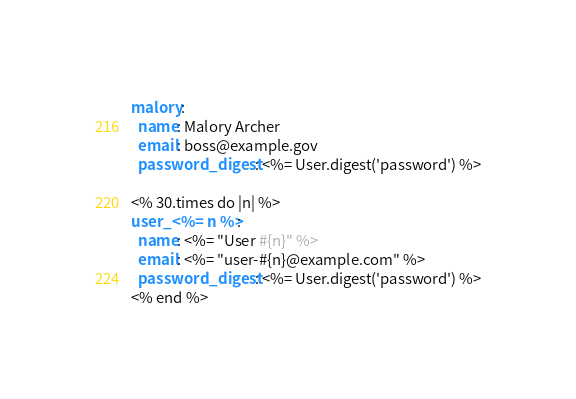Convert code to text. <code><loc_0><loc_0><loc_500><loc_500><_YAML_>malory:
  name: Malory Archer
  email: boss@example.gov
  password_digest: <%= User.digest('password') %>

<% 30.times do |n| %>
user_<%= n %>:
  name: <%= "User #{n}" %>
  email: <%= "user-#{n}@example.com" %>
  password_digest: <%= User.digest('password') %>
<% end %>
</code> 